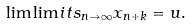Convert formula to latex. <formula><loc_0><loc_0><loc_500><loc_500>\lim \lim i t s _ { n \to \infty } x _ { n + k } = u .</formula> 